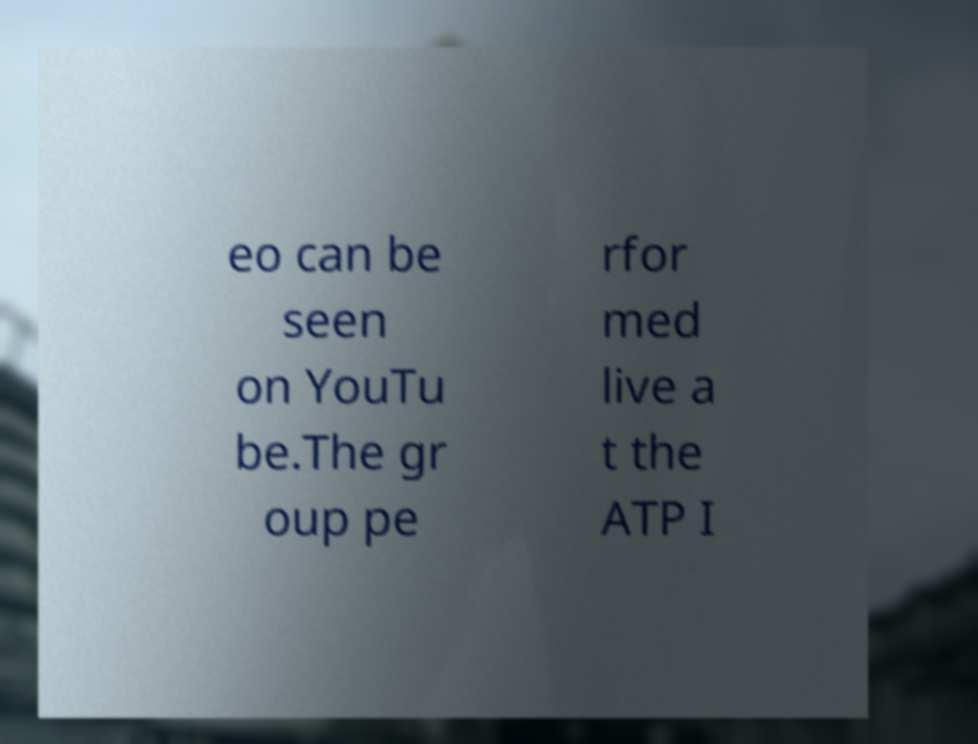Can you read and provide the text displayed in the image?This photo seems to have some interesting text. Can you extract and type it out for me? eo can be seen on YouTu be.The gr oup pe rfor med live a t the ATP I 